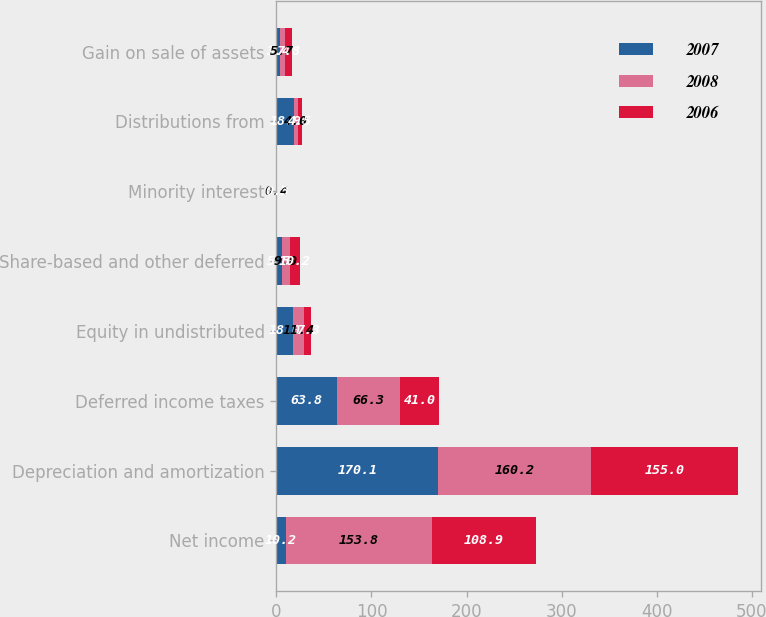<chart> <loc_0><loc_0><loc_500><loc_500><stacked_bar_chart><ecel><fcel>Net income<fcel>Depreciation and amortization<fcel>Deferred income taxes<fcel>Equity in undistributed<fcel>Share-based and other deferred<fcel>Minority interest<fcel>Distributions from<fcel>Gain on sale of assets<nl><fcel>2007<fcel>10.2<fcel>170.1<fcel>63.8<fcel>18<fcel>5.5<fcel>0.3<fcel>18.9<fcel>3.4<nl><fcel>2008<fcel>153.8<fcel>160.2<fcel>66.3<fcel>11.4<fcel>9<fcel>0.4<fcel>4<fcel>5.7<nl><fcel>2006<fcel>108.9<fcel>155<fcel>41<fcel>7.3<fcel>10.2<fcel>0.3<fcel>4.5<fcel>7.8<nl></chart> 